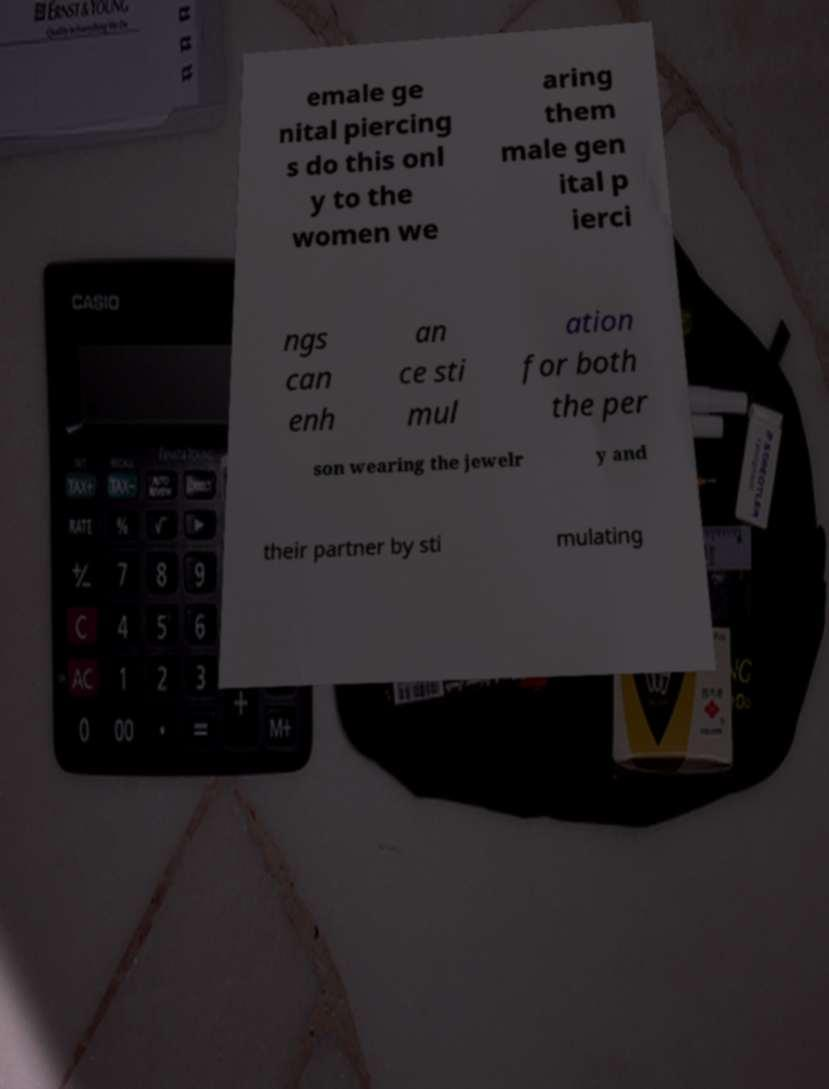Please read and relay the text visible in this image. What does it say? emale ge nital piercing s do this onl y to the women we aring them male gen ital p ierci ngs can enh an ce sti mul ation for both the per son wearing the jewelr y and their partner by sti mulating 